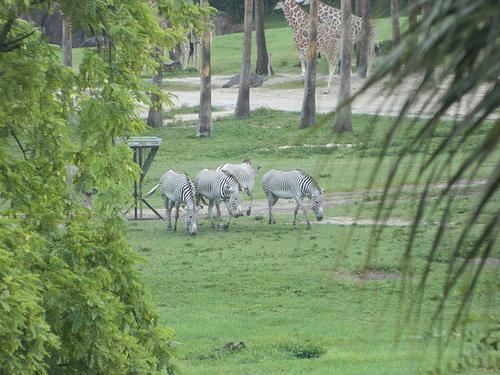How many zebras are there?
Give a very brief answer. 4. 